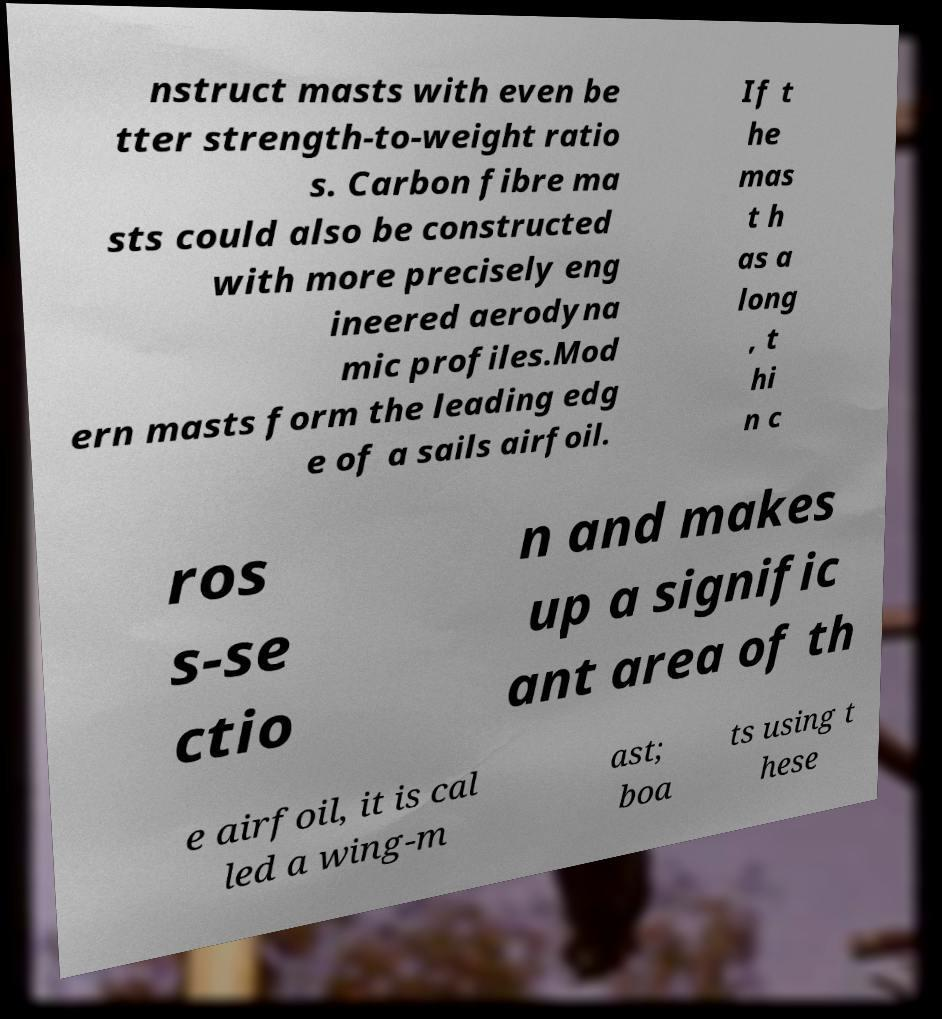Can you accurately transcribe the text from the provided image for me? nstruct masts with even be tter strength-to-weight ratio s. Carbon fibre ma sts could also be constructed with more precisely eng ineered aerodyna mic profiles.Mod ern masts form the leading edg e of a sails airfoil. If t he mas t h as a long , t hi n c ros s-se ctio n and makes up a signific ant area of th e airfoil, it is cal led a wing-m ast; boa ts using t hese 